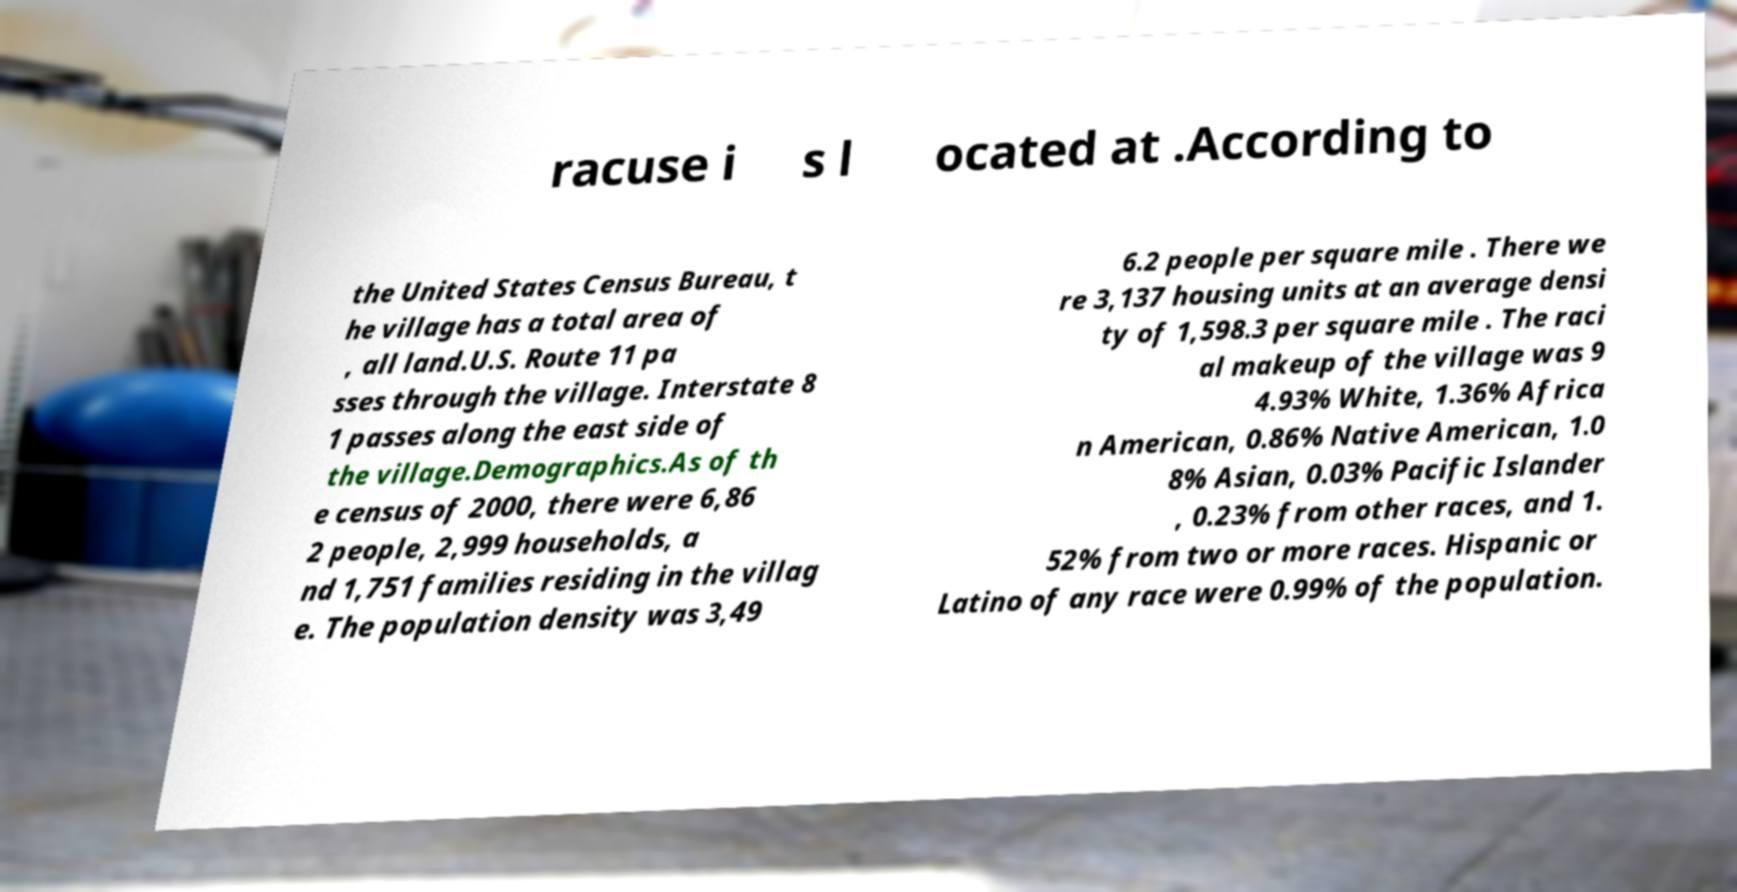What messages or text are displayed in this image? I need them in a readable, typed format. racuse i s l ocated at .According to the United States Census Bureau, t he village has a total area of , all land.U.S. Route 11 pa sses through the village. Interstate 8 1 passes along the east side of the village.Demographics.As of th e census of 2000, there were 6,86 2 people, 2,999 households, a nd 1,751 families residing in the villag e. The population density was 3,49 6.2 people per square mile . There we re 3,137 housing units at an average densi ty of 1,598.3 per square mile . The raci al makeup of the village was 9 4.93% White, 1.36% Africa n American, 0.86% Native American, 1.0 8% Asian, 0.03% Pacific Islander , 0.23% from other races, and 1. 52% from two or more races. Hispanic or Latino of any race were 0.99% of the population. 